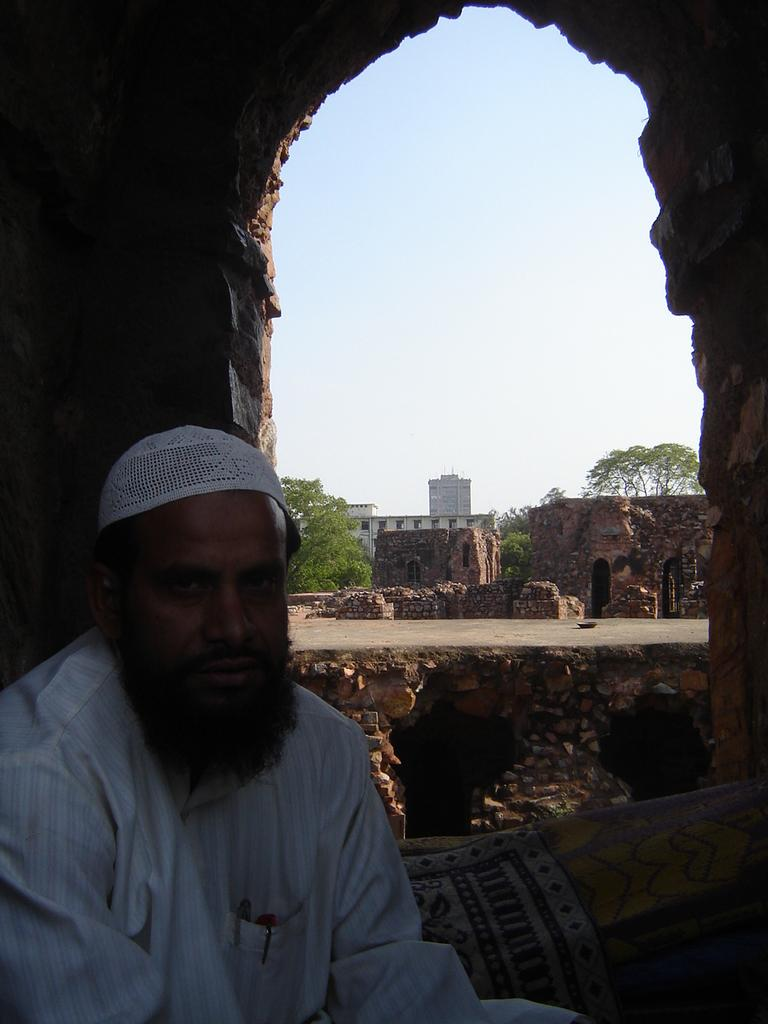Who is present in the image? There is a man in the image. Where is the man located in the image? The man is on the left side of the image. What is the man wearing in the image? The man is wearing clothes and a cap. What architectural feature can be seen in the image? There is an arch in the image. What type of natural elements are present in the image? There are trees in the image. What type of man-made structures are present in the image? There are buildings in the image. What part of the natural environment is visible in the image? The sky is visible in the image. What type of slope can be seen in the image? There is no slope present in the image. 